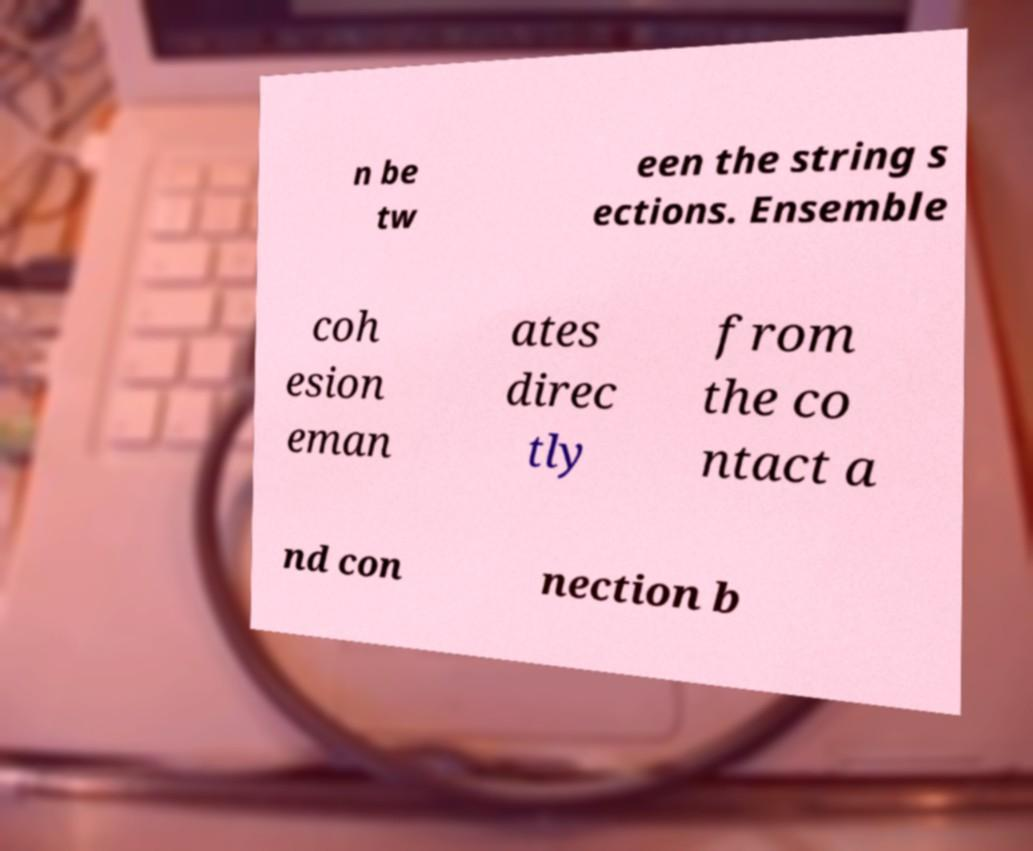Can you read and provide the text displayed in the image?This photo seems to have some interesting text. Can you extract and type it out for me? n be tw een the string s ections. Ensemble coh esion eman ates direc tly from the co ntact a nd con nection b 